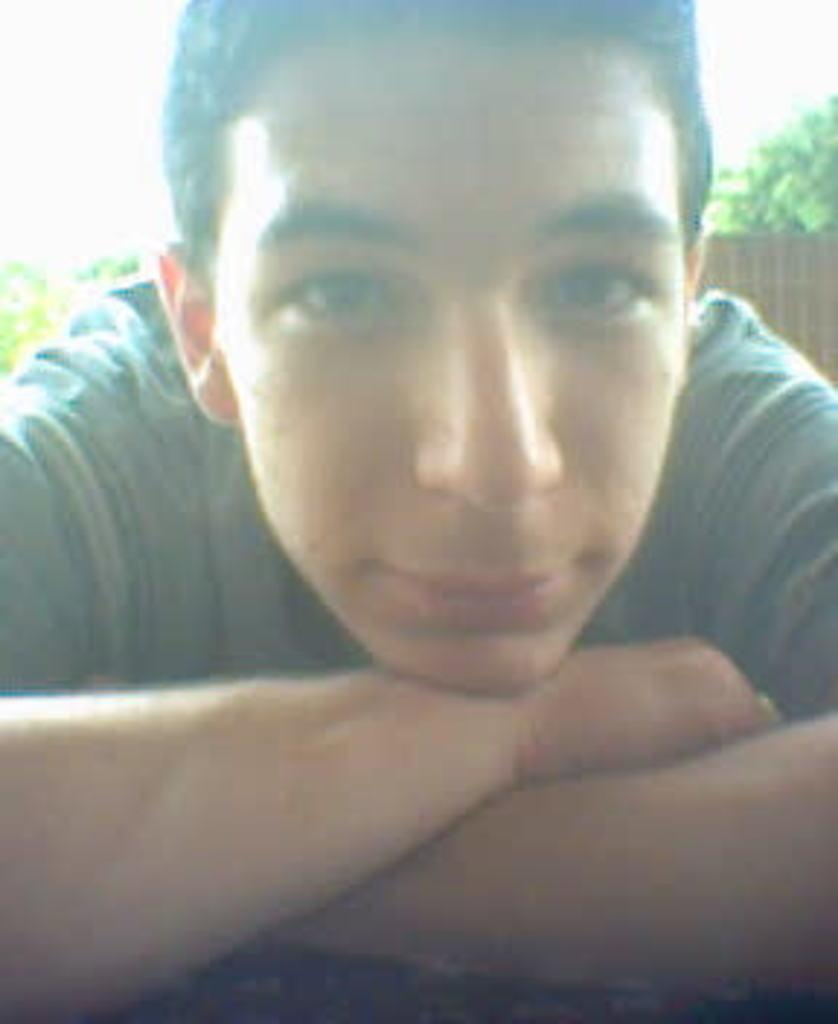What is present in the image? There is a person in the image. What can be seen in the background of the image? There is a wall and trees in the image. What type of bell can be heard ringing in the image? There is no bell present or ringing in the image. What kind of flower is growing near the person in the image? There is no flower visible in the image. 